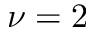Convert formula to latex. <formula><loc_0><loc_0><loc_500><loc_500>\nu = 2</formula> 